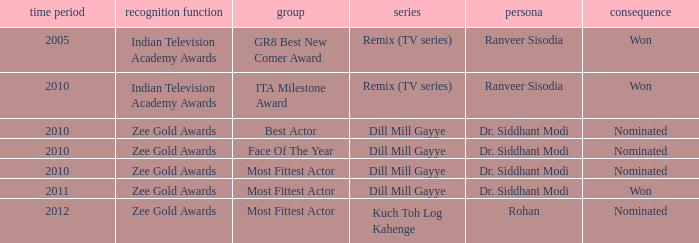Which show has a character of Rohan? Kuch Toh Log Kahenge. 